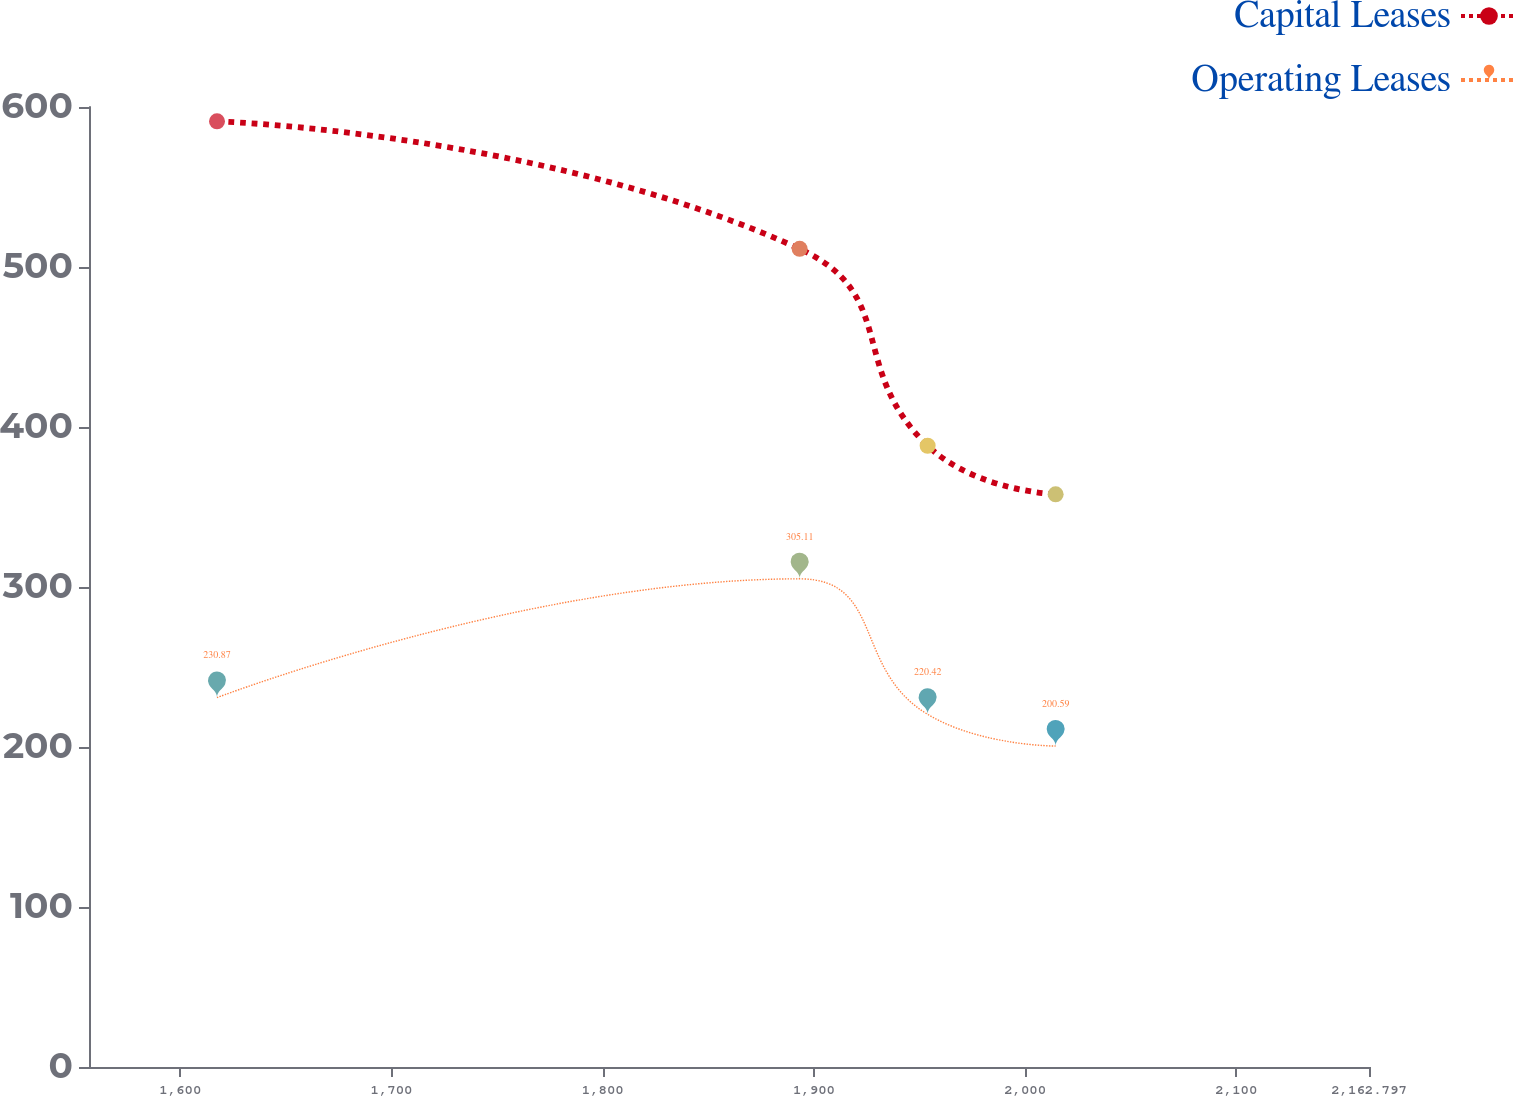Convert chart. <chart><loc_0><loc_0><loc_500><loc_500><line_chart><ecel><fcel>Capital Leases<fcel>Operating Leases<nl><fcel>1617.37<fcel>591.04<fcel>230.87<nl><fcel>1893.23<fcel>511.33<fcel>305.11<nl><fcel>1953.83<fcel>388.3<fcel>220.42<nl><fcel>2014.43<fcel>357.91<fcel>200.59<nl><fcel>2223.4<fcel>287.12<fcel>253.1<nl></chart> 